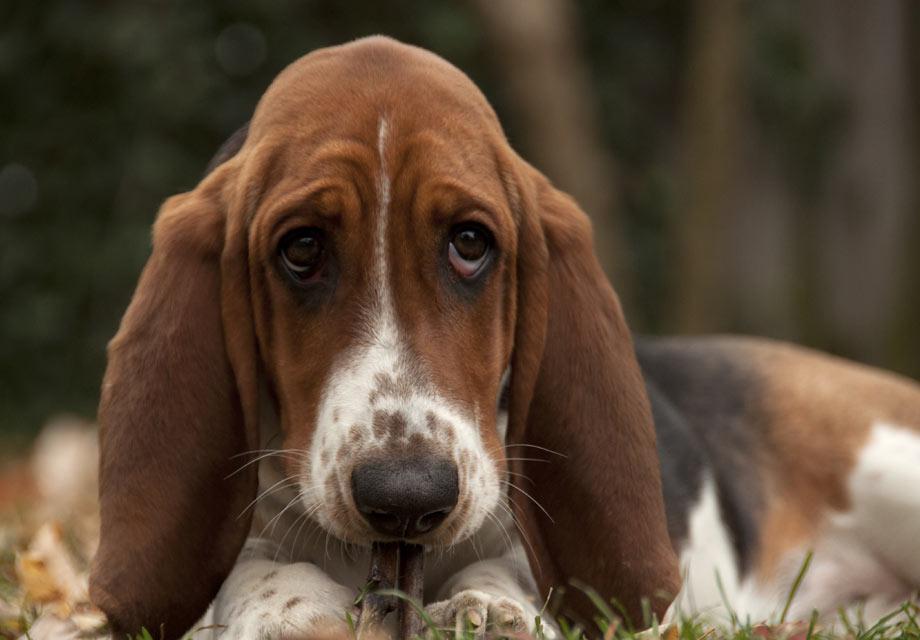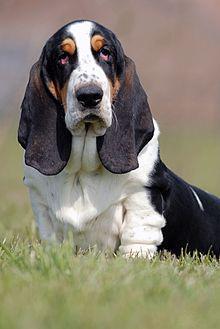The first image is the image on the left, the second image is the image on the right. Assess this claim about the two images: "A hound dog is running forward on the green grass.". Correct or not? Answer yes or no. No. The first image is the image on the left, the second image is the image on the right. Given the left and right images, does the statement "There are two dogs in the image pair." hold true? Answer yes or no. Yes. 